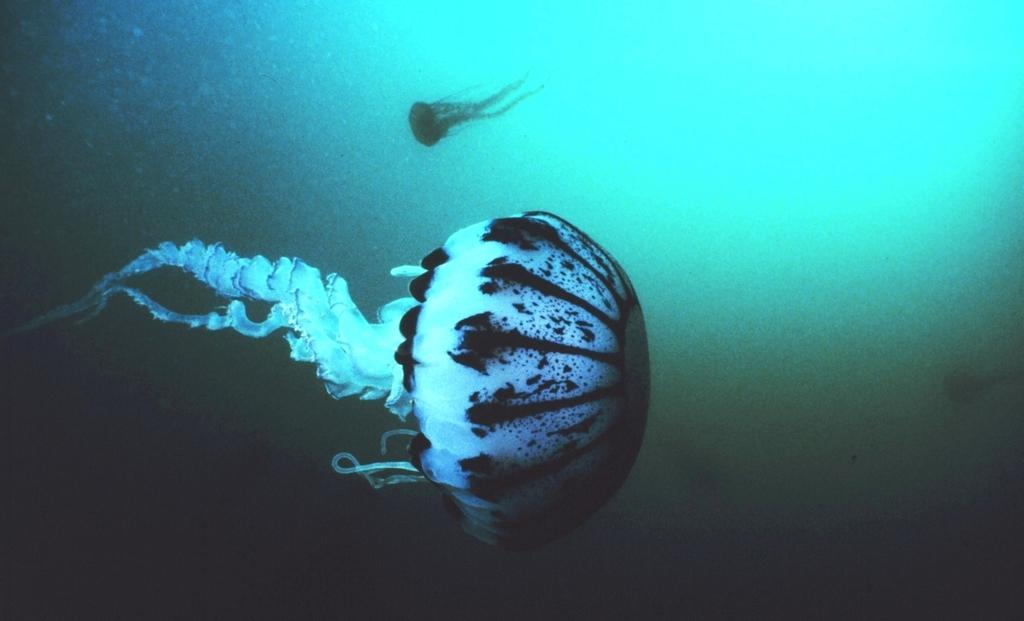What type of environment is depicted in the image? The image shows two ocean biomes. Can you describe the characteristics of these ocean biomes? Unfortunately, the provided facts do not give any specific details about the characteristics of the ocean biomes. Where can you find toothpaste in the image? There is no toothpaste present in the image, as it features two ocean biomes. 